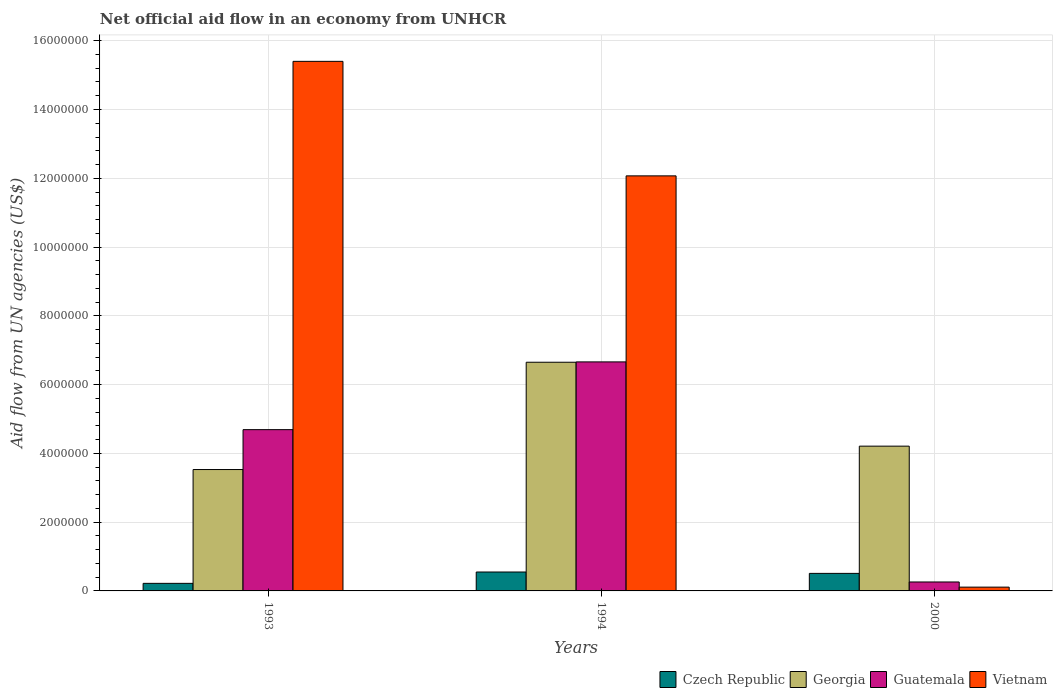How many different coloured bars are there?
Your answer should be compact. 4. How many groups of bars are there?
Keep it short and to the point. 3. Are the number of bars on each tick of the X-axis equal?
Ensure brevity in your answer.  Yes. What is the net official aid flow in Czech Republic in 1993?
Keep it short and to the point. 2.20e+05. Across all years, what is the maximum net official aid flow in Vietnam?
Provide a short and direct response. 1.54e+07. Across all years, what is the minimum net official aid flow in Czech Republic?
Offer a very short reply. 2.20e+05. In which year was the net official aid flow in Vietnam maximum?
Your response must be concise. 1993. What is the total net official aid flow in Georgia in the graph?
Your answer should be very brief. 1.44e+07. What is the difference between the net official aid flow in Vietnam in 1993 and that in 2000?
Your answer should be compact. 1.53e+07. What is the difference between the net official aid flow in Georgia in 1993 and the net official aid flow in Vietnam in 1994?
Offer a terse response. -8.54e+06. What is the average net official aid flow in Georgia per year?
Your answer should be compact. 4.80e+06. In the year 1993, what is the difference between the net official aid flow in Guatemala and net official aid flow in Georgia?
Offer a very short reply. 1.16e+06. In how many years, is the net official aid flow in Georgia greater than 2800000 US$?
Give a very brief answer. 3. What is the ratio of the net official aid flow in Georgia in 1994 to that in 2000?
Offer a very short reply. 1.58. What is the difference between the highest and the second highest net official aid flow in Georgia?
Your answer should be compact. 2.44e+06. What is the difference between the highest and the lowest net official aid flow in Czech Republic?
Offer a terse response. 3.30e+05. In how many years, is the net official aid flow in Czech Republic greater than the average net official aid flow in Czech Republic taken over all years?
Give a very brief answer. 2. What does the 3rd bar from the left in 2000 represents?
Your answer should be compact. Guatemala. What does the 4th bar from the right in 1993 represents?
Offer a very short reply. Czech Republic. Is it the case that in every year, the sum of the net official aid flow in Vietnam and net official aid flow in Georgia is greater than the net official aid flow in Czech Republic?
Offer a terse response. Yes. Are all the bars in the graph horizontal?
Offer a very short reply. No. What is the difference between two consecutive major ticks on the Y-axis?
Offer a very short reply. 2.00e+06. Are the values on the major ticks of Y-axis written in scientific E-notation?
Make the answer very short. No. Does the graph contain any zero values?
Provide a succinct answer. No. How many legend labels are there?
Provide a succinct answer. 4. What is the title of the graph?
Make the answer very short. Net official aid flow in an economy from UNHCR. What is the label or title of the Y-axis?
Offer a terse response. Aid flow from UN agencies (US$). What is the Aid flow from UN agencies (US$) in Czech Republic in 1993?
Make the answer very short. 2.20e+05. What is the Aid flow from UN agencies (US$) of Georgia in 1993?
Your response must be concise. 3.53e+06. What is the Aid flow from UN agencies (US$) in Guatemala in 1993?
Make the answer very short. 4.69e+06. What is the Aid flow from UN agencies (US$) in Vietnam in 1993?
Your answer should be very brief. 1.54e+07. What is the Aid flow from UN agencies (US$) in Czech Republic in 1994?
Provide a succinct answer. 5.50e+05. What is the Aid flow from UN agencies (US$) in Georgia in 1994?
Your response must be concise. 6.65e+06. What is the Aid flow from UN agencies (US$) of Guatemala in 1994?
Make the answer very short. 6.66e+06. What is the Aid flow from UN agencies (US$) in Vietnam in 1994?
Give a very brief answer. 1.21e+07. What is the Aid flow from UN agencies (US$) in Czech Republic in 2000?
Your answer should be compact. 5.10e+05. What is the Aid flow from UN agencies (US$) of Georgia in 2000?
Provide a succinct answer. 4.21e+06. What is the Aid flow from UN agencies (US$) in Guatemala in 2000?
Provide a succinct answer. 2.60e+05. Across all years, what is the maximum Aid flow from UN agencies (US$) of Georgia?
Ensure brevity in your answer.  6.65e+06. Across all years, what is the maximum Aid flow from UN agencies (US$) of Guatemala?
Provide a succinct answer. 6.66e+06. Across all years, what is the maximum Aid flow from UN agencies (US$) in Vietnam?
Offer a terse response. 1.54e+07. Across all years, what is the minimum Aid flow from UN agencies (US$) in Czech Republic?
Your response must be concise. 2.20e+05. Across all years, what is the minimum Aid flow from UN agencies (US$) of Georgia?
Offer a terse response. 3.53e+06. Across all years, what is the minimum Aid flow from UN agencies (US$) of Vietnam?
Make the answer very short. 1.10e+05. What is the total Aid flow from UN agencies (US$) of Czech Republic in the graph?
Your response must be concise. 1.28e+06. What is the total Aid flow from UN agencies (US$) of Georgia in the graph?
Provide a succinct answer. 1.44e+07. What is the total Aid flow from UN agencies (US$) of Guatemala in the graph?
Give a very brief answer. 1.16e+07. What is the total Aid flow from UN agencies (US$) of Vietnam in the graph?
Offer a very short reply. 2.76e+07. What is the difference between the Aid flow from UN agencies (US$) in Czech Republic in 1993 and that in 1994?
Your response must be concise. -3.30e+05. What is the difference between the Aid flow from UN agencies (US$) of Georgia in 1993 and that in 1994?
Your answer should be compact. -3.12e+06. What is the difference between the Aid flow from UN agencies (US$) in Guatemala in 1993 and that in 1994?
Offer a very short reply. -1.97e+06. What is the difference between the Aid flow from UN agencies (US$) in Vietnam in 1993 and that in 1994?
Ensure brevity in your answer.  3.33e+06. What is the difference between the Aid flow from UN agencies (US$) in Czech Republic in 1993 and that in 2000?
Provide a succinct answer. -2.90e+05. What is the difference between the Aid flow from UN agencies (US$) of Georgia in 1993 and that in 2000?
Your answer should be compact. -6.80e+05. What is the difference between the Aid flow from UN agencies (US$) of Guatemala in 1993 and that in 2000?
Provide a short and direct response. 4.43e+06. What is the difference between the Aid flow from UN agencies (US$) of Vietnam in 1993 and that in 2000?
Your answer should be compact. 1.53e+07. What is the difference between the Aid flow from UN agencies (US$) in Czech Republic in 1994 and that in 2000?
Give a very brief answer. 4.00e+04. What is the difference between the Aid flow from UN agencies (US$) of Georgia in 1994 and that in 2000?
Offer a terse response. 2.44e+06. What is the difference between the Aid flow from UN agencies (US$) of Guatemala in 1994 and that in 2000?
Offer a very short reply. 6.40e+06. What is the difference between the Aid flow from UN agencies (US$) in Vietnam in 1994 and that in 2000?
Provide a succinct answer. 1.20e+07. What is the difference between the Aid flow from UN agencies (US$) of Czech Republic in 1993 and the Aid flow from UN agencies (US$) of Georgia in 1994?
Offer a very short reply. -6.43e+06. What is the difference between the Aid flow from UN agencies (US$) in Czech Republic in 1993 and the Aid flow from UN agencies (US$) in Guatemala in 1994?
Offer a terse response. -6.44e+06. What is the difference between the Aid flow from UN agencies (US$) of Czech Republic in 1993 and the Aid flow from UN agencies (US$) of Vietnam in 1994?
Ensure brevity in your answer.  -1.18e+07. What is the difference between the Aid flow from UN agencies (US$) of Georgia in 1993 and the Aid flow from UN agencies (US$) of Guatemala in 1994?
Your answer should be very brief. -3.13e+06. What is the difference between the Aid flow from UN agencies (US$) of Georgia in 1993 and the Aid flow from UN agencies (US$) of Vietnam in 1994?
Your response must be concise. -8.54e+06. What is the difference between the Aid flow from UN agencies (US$) in Guatemala in 1993 and the Aid flow from UN agencies (US$) in Vietnam in 1994?
Ensure brevity in your answer.  -7.38e+06. What is the difference between the Aid flow from UN agencies (US$) in Czech Republic in 1993 and the Aid flow from UN agencies (US$) in Georgia in 2000?
Give a very brief answer. -3.99e+06. What is the difference between the Aid flow from UN agencies (US$) in Czech Republic in 1993 and the Aid flow from UN agencies (US$) in Guatemala in 2000?
Your answer should be compact. -4.00e+04. What is the difference between the Aid flow from UN agencies (US$) of Georgia in 1993 and the Aid flow from UN agencies (US$) of Guatemala in 2000?
Provide a short and direct response. 3.27e+06. What is the difference between the Aid flow from UN agencies (US$) of Georgia in 1993 and the Aid flow from UN agencies (US$) of Vietnam in 2000?
Make the answer very short. 3.42e+06. What is the difference between the Aid flow from UN agencies (US$) of Guatemala in 1993 and the Aid flow from UN agencies (US$) of Vietnam in 2000?
Ensure brevity in your answer.  4.58e+06. What is the difference between the Aid flow from UN agencies (US$) of Czech Republic in 1994 and the Aid flow from UN agencies (US$) of Georgia in 2000?
Your answer should be very brief. -3.66e+06. What is the difference between the Aid flow from UN agencies (US$) of Georgia in 1994 and the Aid flow from UN agencies (US$) of Guatemala in 2000?
Your answer should be very brief. 6.39e+06. What is the difference between the Aid flow from UN agencies (US$) of Georgia in 1994 and the Aid flow from UN agencies (US$) of Vietnam in 2000?
Make the answer very short. 6.54e+06. What is the difference between the Aid flow from UN agencies (US$) of Guatemala in 1994 and the Aid flow from UN agencies (US$) of Vietnam in 2000?
Provide a succinct answer. 6.55e+06. What is the average Aid flow from UN agencies (US$) of Czech Republic per year?
Ensure brevity in your answer.  4.27e+05. What is the average Aid flow from UN agencies (US$) in Georgia per year?
Provide a short and direct response. 4.80e+06. What is the average Aid flow from UN agencies (US$) in Guatemala per year?
Offer a terse response. 3.87e+06. What is the average Aid flow from UN agencies (US$) of Vietnam per year?
Ensure brevity in your answer.  9.19e+06. In the year 1993, what is the difference between the Aid flow from UN agencies (US$) in Czech Republic and Aid flow from UN agencies (US$) in Georgia?
Ensure brevity in your answer.  -3.31e+06. In the year 1993, what is the difference between the Aid flow from UN agencies (US$) in Czech Republic and Aid flow from UN agencies (US$) in Guatemala?
Keep it short and to the point. -4.47e+06. In the year 1993, what is the difference between the Aid flow from UN agencies (US$) of Czech Republic and Aid flow from UN agencies (US$) of Vietnam?
Provide a succinct answer. -1.52e+07. In the year 1993, what is the difference between the Aid flow from UN agencies (US$) of Georgia and Aid flow from UN agencies (US$) of Guatemala?
Keep it short and to the point. -1.16e+06. In the year 1993, what is the difference between the Aid flow from UN agencies (US$) of Georgia and Aid flow from UN agencies (US$) of Vietnam?
Provide a short and direct response. -1.19e+07. In the year 1993, what is the difference between the Aid flow from UN agencies (US$) in Guatemala and Aid flow from UN agencies (US$) in Vietnam?
Provide a succinct answer. -1.07e+07. In the year 1994, what is the difference between the Aid flow from UN agencies (US$) of Czech Republic and Aid flow from UN agencies (US$) of Georgia?
Offer a very short reply. -6.10e+06. In the year 1994, what is the difference between the Aid flow from UN agencies (US$) in Czech Republic and Aid flow from UN agencies (US$) in Guatemala?
Ensure brevity in your answer.  -6.11e+06. In the year 1994, what is the difference between the Aid flow from UN agencies (US$) in Czech Republic and Aid flow from UN agencies (US$) in Vietnam?
Ensure brevity in your answer.  -1.15e+07. In the year 1994, what is the difference between the Aid flow from UN agencies (US$) of Georgia and Aid flow from UN agencies (US$) of Vietnam?
Your answer should be very brief. -5.42e+06. In the year 1994, what is the difference between the Aid flow from UN agencies (US$) of Guatemala and Aid flow from UN agencies (US$) of Vietnam?
Offer a terse response. -5.41e+06. In the year 2000, what is the difference between the Aid flow from UN agencies (US$) of Czech Republic and Aid flow from UN agencies (US$) of Georgia?
Offer a very short reply. -3.70e+06. In the year 2000, what is the difference between the Aid flow from UN agencies (US$) in Georgia and Aid flow from UN agencies (US$) in Guatemala?
Offer a very short reply. 3.95e+06. In the year 2000, what is the difference between the Aid flow from UN agencies (US$) in Georgia and Aid flow from UN agencies (US$) in Vietnam?
Your response must be concise. 4.10e+06. In the year 2000, what is the difference between the Aid flow from UN agencies (US$) of Guatemala and Aid flow from UN agencies (US$) of Vietnam?
Provide a succinct answer. 1.50e+05. What is the ratio of the Aid flow from UN agencies (US$) of Georgia in 1993 to that in 1994?
Give a very brief answer. 0.53. What is the ratio of the Aid flow from UN agencies (US$) in Guatemala in 1993 to that in 1994?
Provide a succinct answer. 0.7. What is the ratio of the Aid flow from UN agencies (US$) in Vietnam in 1993 to that in 1994?
Offer a terse response. 1.28. What is the ratio of the Aid flow from UN agencies (US$) in Czech Republic in 1993 to that in 2000?
Give a very brief answer. 0.43. What is the ratio of the Aid flow from UN agencies (US$) in Georgia in 1993 to that in 2000?
Your answer should be compact. 0.84. What is the ratio of the Aid flow from UN agencies (US$) in Guatemala in 1993 to that in 2000?
Make the answer very short. 18.04. What is the ratio of the Aid flow from UN agencies (US$) in Vietnam in 1993 to that in 2000?
Make the answer very short. 140. What is the ratio of the Aid flow from UN agencies (US$) of Czech Republic in 1994 to that in 2000?
Offer a terse response. 1.08. What is the ratio of the Aid flow from UN agencies (US$) of Georgia in 1994 to that in 2000?
Your response must be concise. 1.58. What is the ratio of the Aid flow from UN agencies (US$) in Guatemala in 1994 to that in 2000?
Keep it short and to the point. 25.62. What is the ratio of the Aid flow from UN agencies (US$) in Vietnam in 1994 to that in 2000?
Offer a terse response. 109.73. What is the difference between the highest and the second highest Aid flow from UN agencies (US$) of Georgia?
Provide a succinct answer. 2.44e+06. What is the difference between the highest and the second highest Aid flow from UN agencies (US$) in Guatemala?
Make the answer very short. 1.97e+06. What is the difference between the highest and the second highest Aid flow from UN agencies (US$) in Vietnam?
Keep it short and to the point. 3.33e+06. What is the difference between the highest and the lowest Aid flow from UN agencies (US$) in Czech Republic?
Provide a succinct answer. 3.30e+05. What is the difference between the highest and the lowest Aid flow from UN agencies (US$) of Georgia?
Keep it short and to the point. 3.12e+06. What is the difference between the highest and the lowest Aid flow from UN agencies (US$) of Guatemala?
Make the answer very short. 6.40e+06. What is the difference between the highest and the lowest Aid flow from UN agencies (US$) of Vietnam?
Make the answer very short. 1.53e+07. 